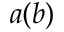Convert formula to latex. <formula><loc_0><loc_0><loc_500><loc_500>a ( b )</formula> 